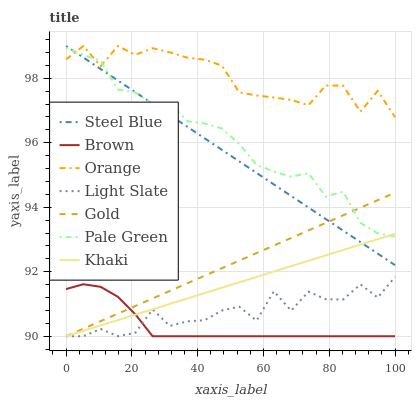Does Brown have the minimum area under the curve?
Answer yes or no. Yes. Does Orange have the maximum area under the curve?
Answer yes or no. Yes. Does Khaki have the minimum area under the curve?
Answer yes or no. No. Does Khaki have the maximum area under the curve?
Answer yes or no. No. Is Steel Blue the smoothest?
Answer yes or no. Yes. Is Light Slate the roughest?
Answer yes or no. Yes. Is Khaki the smoothest?
Answer yes or no. No. Is Khaki the roughest?
Answer yes or no. No. Does Brown have the lowest value?
Answer yes or no. Yes. Does Steel Blue have the lowest value?
Answer yes or no. No. Does Orange have the highest value?
Answer yes or no. Yes. Does Khaki have the highest value?
Answer yes or no. No. Is Brown less than Pale Green?
Answer yes or no. Yes. Is Orange greater than Brown?
Answer yes or no. Yes. Does Khaki intersect Pale Green?
Answer yes or no. Yes. Is Khaki less than Pale Green?
Answer yes or no. No. Is Khaki greater than Pale Green?
Answer yes or no. No. Does Brown intersect Pale Green?
Answer yes or no. No. 